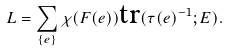Convert formula to latex. <formula><loc_0><loc_0><loc_500><loc_500>L = \sum _ { \{ e \} } \chi ( F ( e ) ) \text {tr} ( \tau ( e ) ^ { - 1 } ; E ) .</formula> 